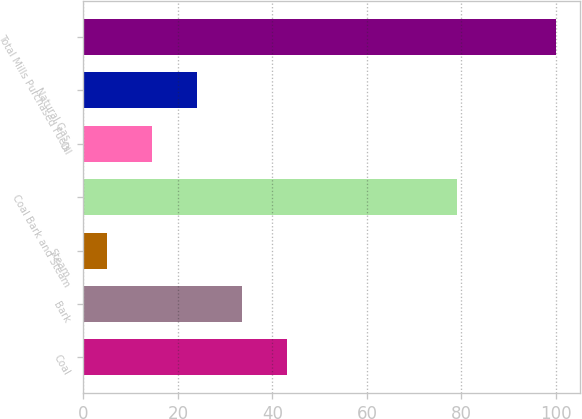Convert chart to OTSL. <chart><loc_0><loc_0><loc_500><loc_500><bar_chart><fcel>Coal<fcel>Bark<fcel>Steam<fcel>Coal Bark and Steam<fcel>Oil<fcel>Natural Gas<fcel>Total Mills Purchased Fuels<nl><fcel>43<fcel>33.5<fcel>5<fcel>79<fcel>14.5<fcel>24<fcel>100<nl></chart> 